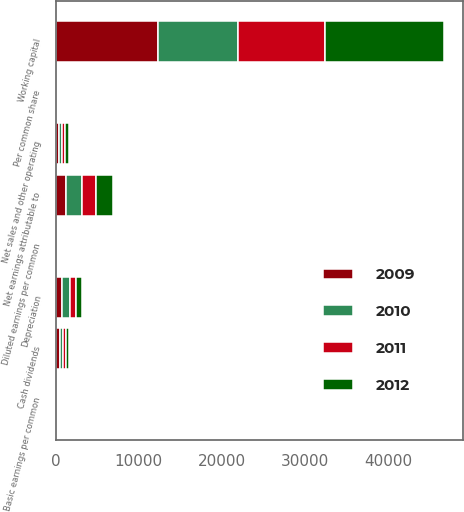Convert chart to OTSL. <chart><loc_0><loc_0><loc_500><loc_500><stacked_bar_chart><ecel><fcel>Net sales and other operating<fcel>Depreciation<fcel>Net earnings attributable to<fcel>Basic earnings per common<fcel>Diluted earnings per common<fcel>Cash dividends<fcel>Per common share<fcel>Working capital<nl><fcel>2009<fcel>383.5<fcel>793<fcel>1223<fcel>1.84<fcel>1.84<fcel>455<fcel>0.69<fcel>12328<nl><fcel>2012<fcel>383.5<fcel>827<fcel>2036<fcel>3.17<fcel>3.13<fcel>395<fcel>0.62<fcel>14286<nl><fcel>2010<fcel>383.5<fcel>857<fcel>1930<fcel>3<fcel>3<fcel>372<fcel>0.58<fcel>9561<nl><fcel>2011<fcel>383.5<fcel>730<fcel>1684<fcel>2.62<fcel>2.62<fcel>347<fcel>0.54<fcel>10523<nl></chart> 